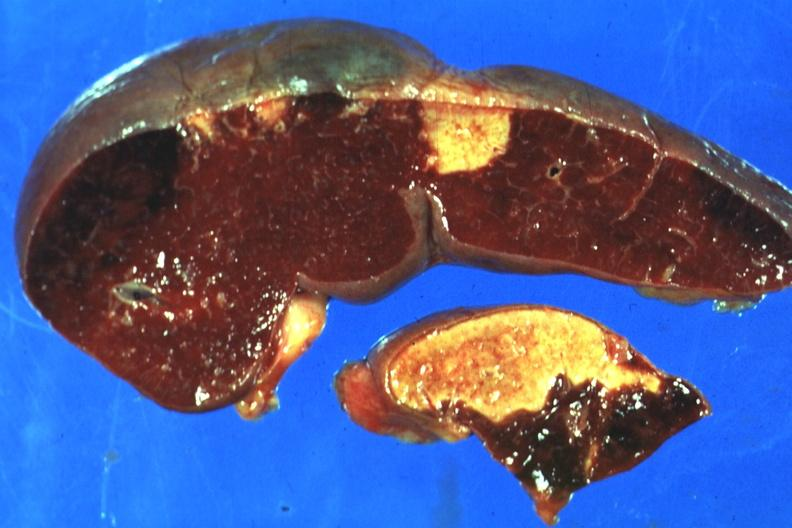where is this part in?
Answer the question using a single word or phrase. Spleen 